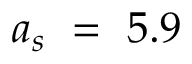Convert formula to latex. <formula><loc_0><loc_0><loc_500><loc_500>a _ { s } = 5 . 9</formula> 